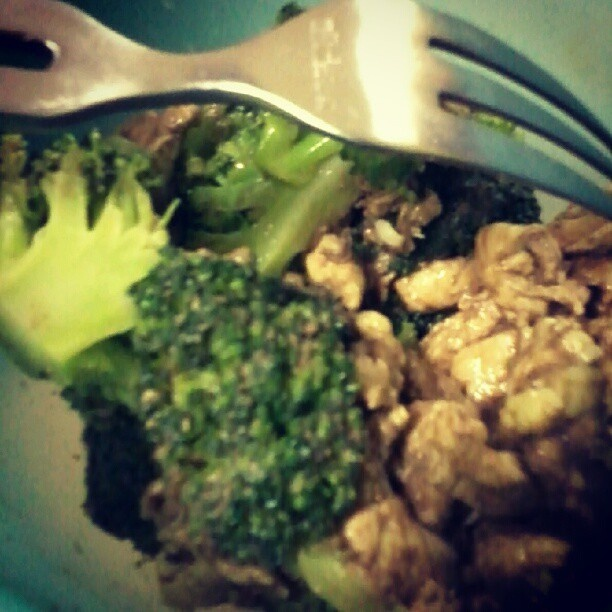Describe the objects in this image and their specific colors. I can see broccoli in brown, black, darkgreen, and olive tones and fork in brown, khaki, lightyellow, gray, and tan tones in this image. 